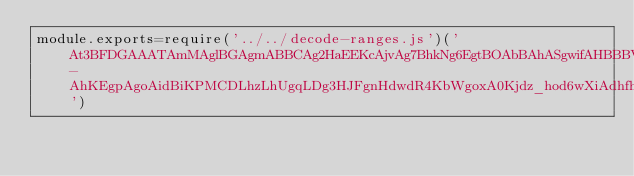Convert code to text. <code><loc_0><loc_0><loc_500><loc_500><_JavaScript_>module.exports=require('../../decode-ranges.js')('At3BFDGAAATAmMAglBGAgmABBCAg2HaEEKcAjvAg7BhkNg6EgtBOAbBAhASgwifAHBBBVAGAACDBIBBBDHADBAEBVECAFDBBVAGABABABBAAEDBBCCAGDAAGPKCAIACAVAGABAEBJACACBAODBLOCAHBBBVAGABAEBIBBBCHBDBAEBRJBAFCCADCBAAABCBCCCLDECCADBAFANUEDAHACAWAPCHACADGBABFDBJHHACAHACAWAJAEBIACADGBGAADBJABNCAHACAgoBHACAEHAHDBPCGBBARCXAIAABGCADFAAAHFJBCLg5DcgkBAABBAABAFDAGACAAAABBAMACBEAAAFBJBDfhHAgjDgmAgjAOAMgkjFAAEABl4ADBGAAADBgoADBggADBGAAADBOAg4ADBhCBfCZFhUKqcChYGMAGKWITLMACABLhdBJFJFOAJFhXHgqEhFJeALDLDACgpBEKgrDZFKCg9BhAAcBKFJFNBOhAhLDgsChzHg7COCgyg_HHgmABFj1FkZBFBglBFBHAAAAAAAeBg0AOANBFASBCAIAhkALBaAMCdRggOiJFpqEgmYKUwcTBfBghCLAHgtguAguAiTEgsAAEABg3GBNXIGAGAGAGAGAGAGAGAhig8ZAhYLjVZLDg_AhVBhmEgoChdAgqEgjLguAjeAxq1J1IMgywSMCg2IlbThdAhYHiOAdBBhEg0DJFg3HhEILFbDhTKdChNAKDggAg2INBJBhmXbJFBFBFIGAGAgvDBhZgtBJFyujLWDgwDyJtBhpglGLEEZAEAAABABAh7QlsPg_Bg1gnNBZFNBgiASADDEAiGBAAi9CFBFBFBCCGAGJEBLAZASABAOBNghh6ECDgsChVCLDAgugtiBcCgwObDgjLaEgqEdAgkDNgpidBJhVgnHgzKAiPk2IVJHiXFBAAgrABCABWAhHHIhPbCaEAg_g3FBg_DABEHACAaDCDIHIGg_fgmDLIg1CcBaEZGDLGhPhIoWemAhNDdOhCNYGJFg0ANLgmIhIDABKFTKRAgqhxg6EJGCAHBBBVAGABAEBIBBBCIAEGBGCEkKhHHJilg1BRg1hEKJglg3HJnVhSLAm_g4wUGuYhmhuAEwuKwQuzPQo4GeAJDBhfdBFJhFJJAGAUEStvhEKguPQ0BfBwv9hqEMCIGJBHxNbj1JgmBi0ghhFi5hWIRiNhUAhGABBABBBDALAAAGAhAADBHAGAbADAEAACGAlTBkjBgxw__jEBPwUoDAaABAABAAJADAAAAFADAAAAAACABAABAAAAAAAAAABAABDAGADADAAAJAQECAEAQgzBkNgrDhjLOBOAOAgkJMCeAg7DgqhKcMgqEIGBitgsChNBhOEgjHj-AhKEgpAgoAidBiKPMCDLhzLhUgqLDg3HJFgnHdwdR4KbWgoxA0Kjdz_hod6wXiAdhfh_jv4P4P4P_9B4P_9')</code> 